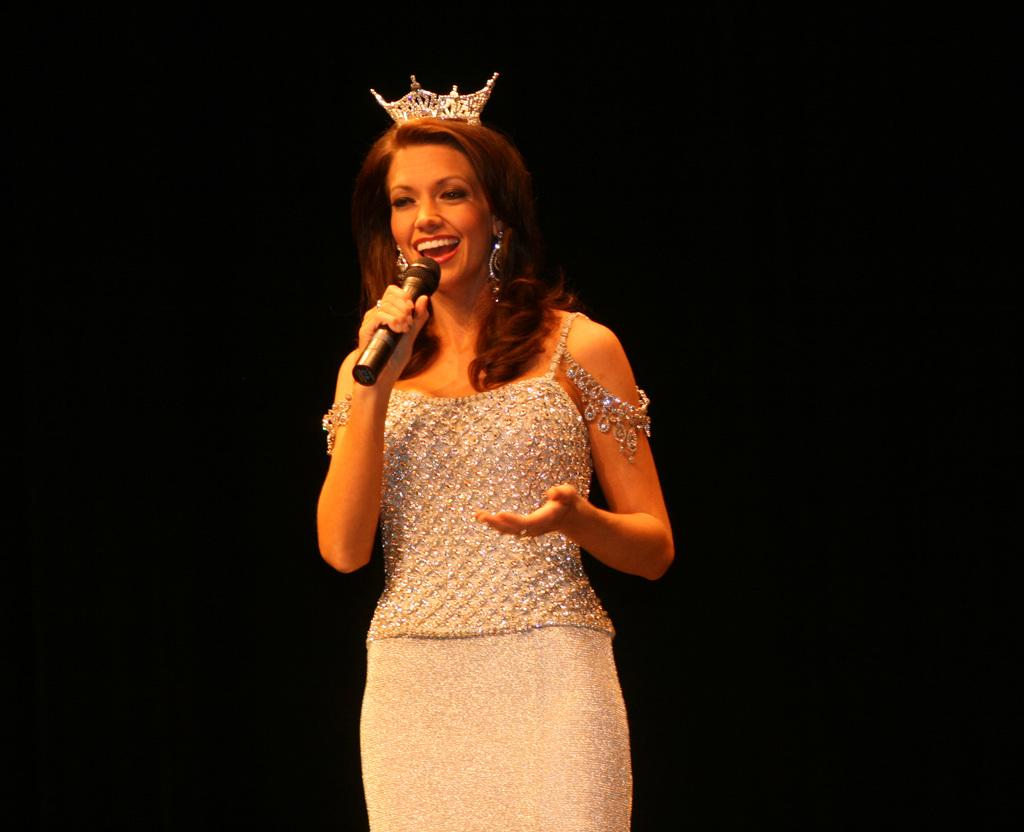Who is in the image? There is a person in the image. What is the person doing in the image? The person is smiling and holding a microphone. What type of tax is being discussed in the image? There is no discussion of tax in the image; it features a person smiling and holding a microphone. 